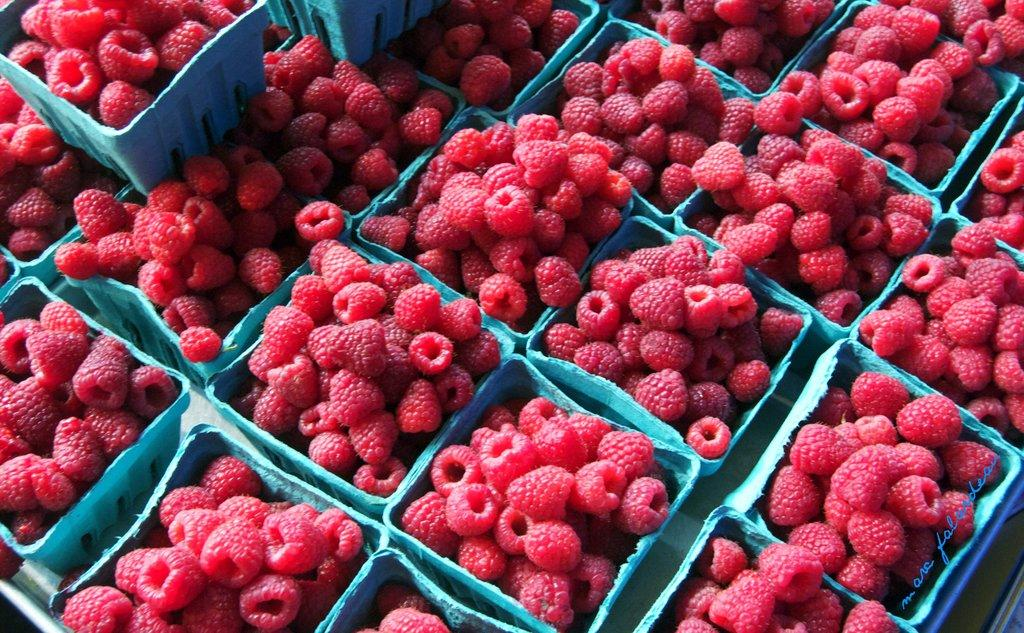What type of food items are present in the image? There are fruits in the image. How are the fruits arranged or contained in the image? The fruits are in blue color baskets. Can you describe any specific fruit in the image? There is a red-colored fruit in the image. How many boats can be seen sailing in the image? There are no boats present in the image; it features fruits in blue color baskets. Is there a faucet visible in the image? There is no faucet present in the image; it features fruits in blue color baskets. 